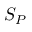<formula> <loc_0><loc_0><loc_500><loc_500>S _ { P }</formula> 